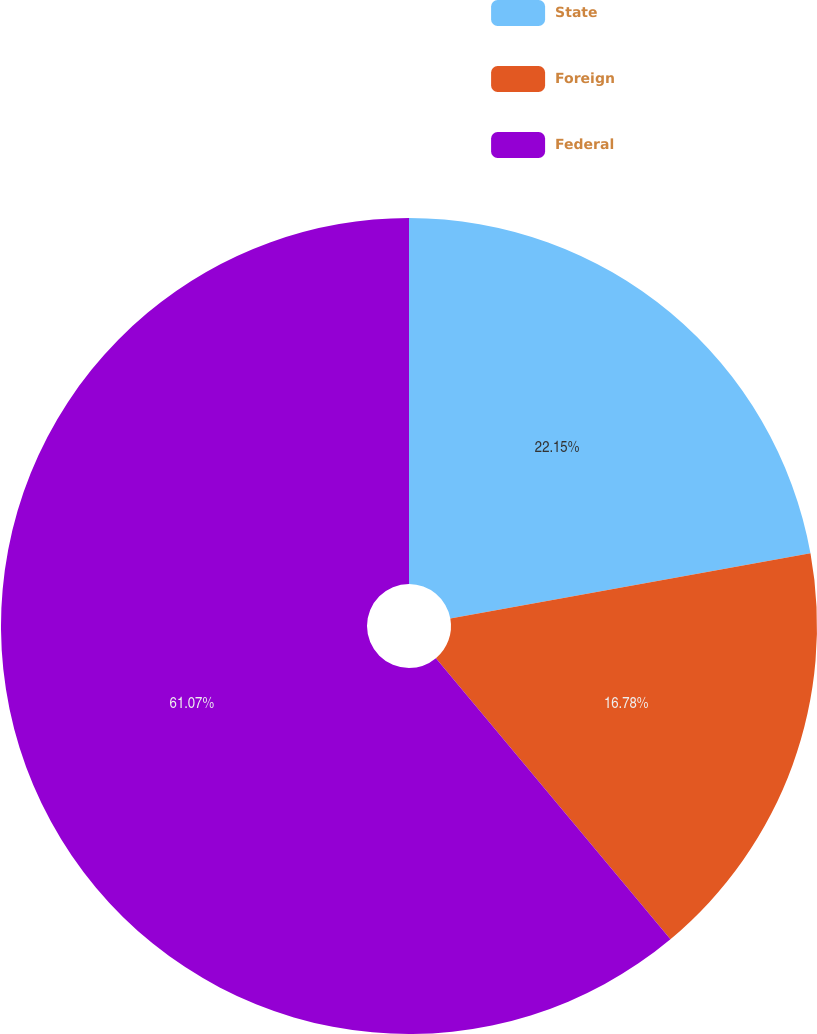Convert chart. <chart><loc_0><loc_0><loc_500><loc_500><pie_chart><fcel>State<fcel>Foreign<fcel>Federal<nl><fcel>22.15%<fcel>16.78%<fcel>61.07%<nl></chart> 